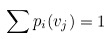<formula> <loc_0><loc_0><loc_500><loc_500>\sum p _ { i } ( v _ { j } ) = 1</formula> 